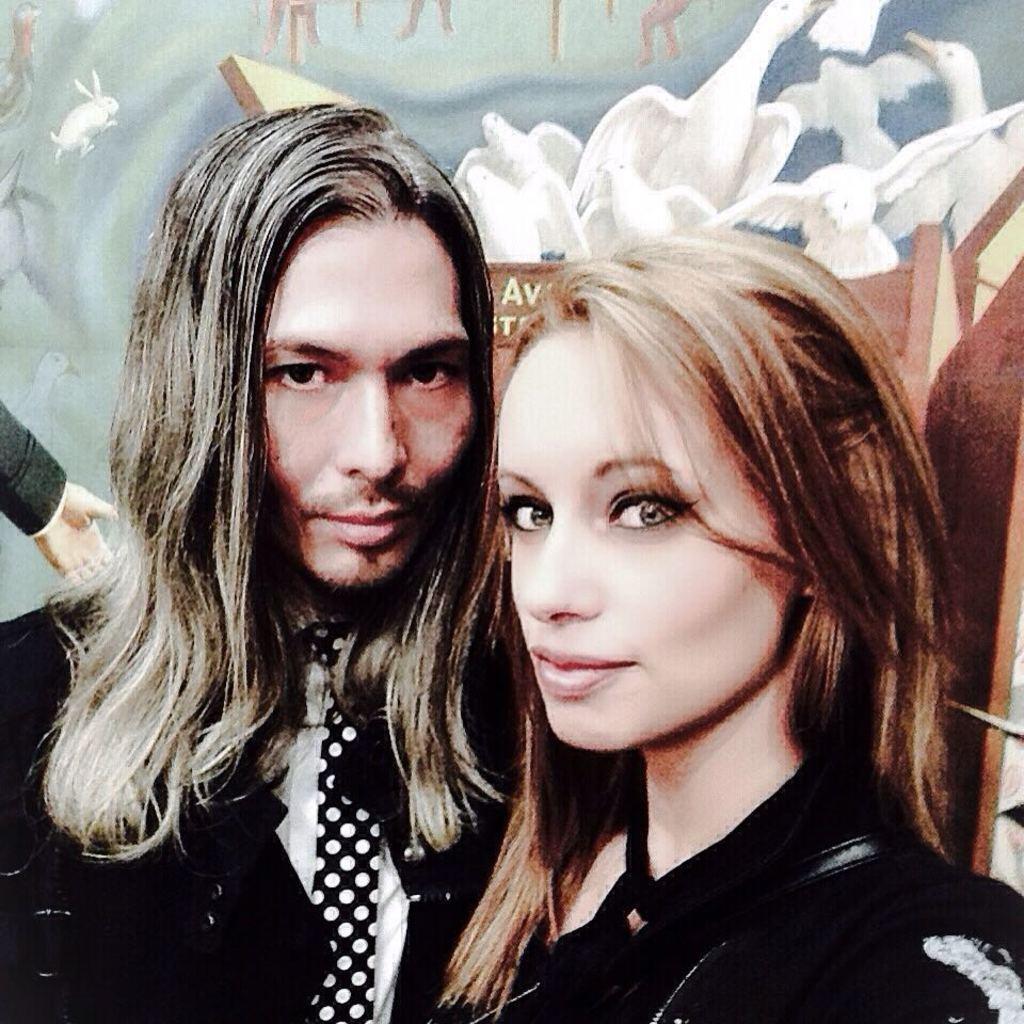Could you give a brief overview of what you see in this image? In this picture I can see a man and a woman, and in the background there is a wall poster. 